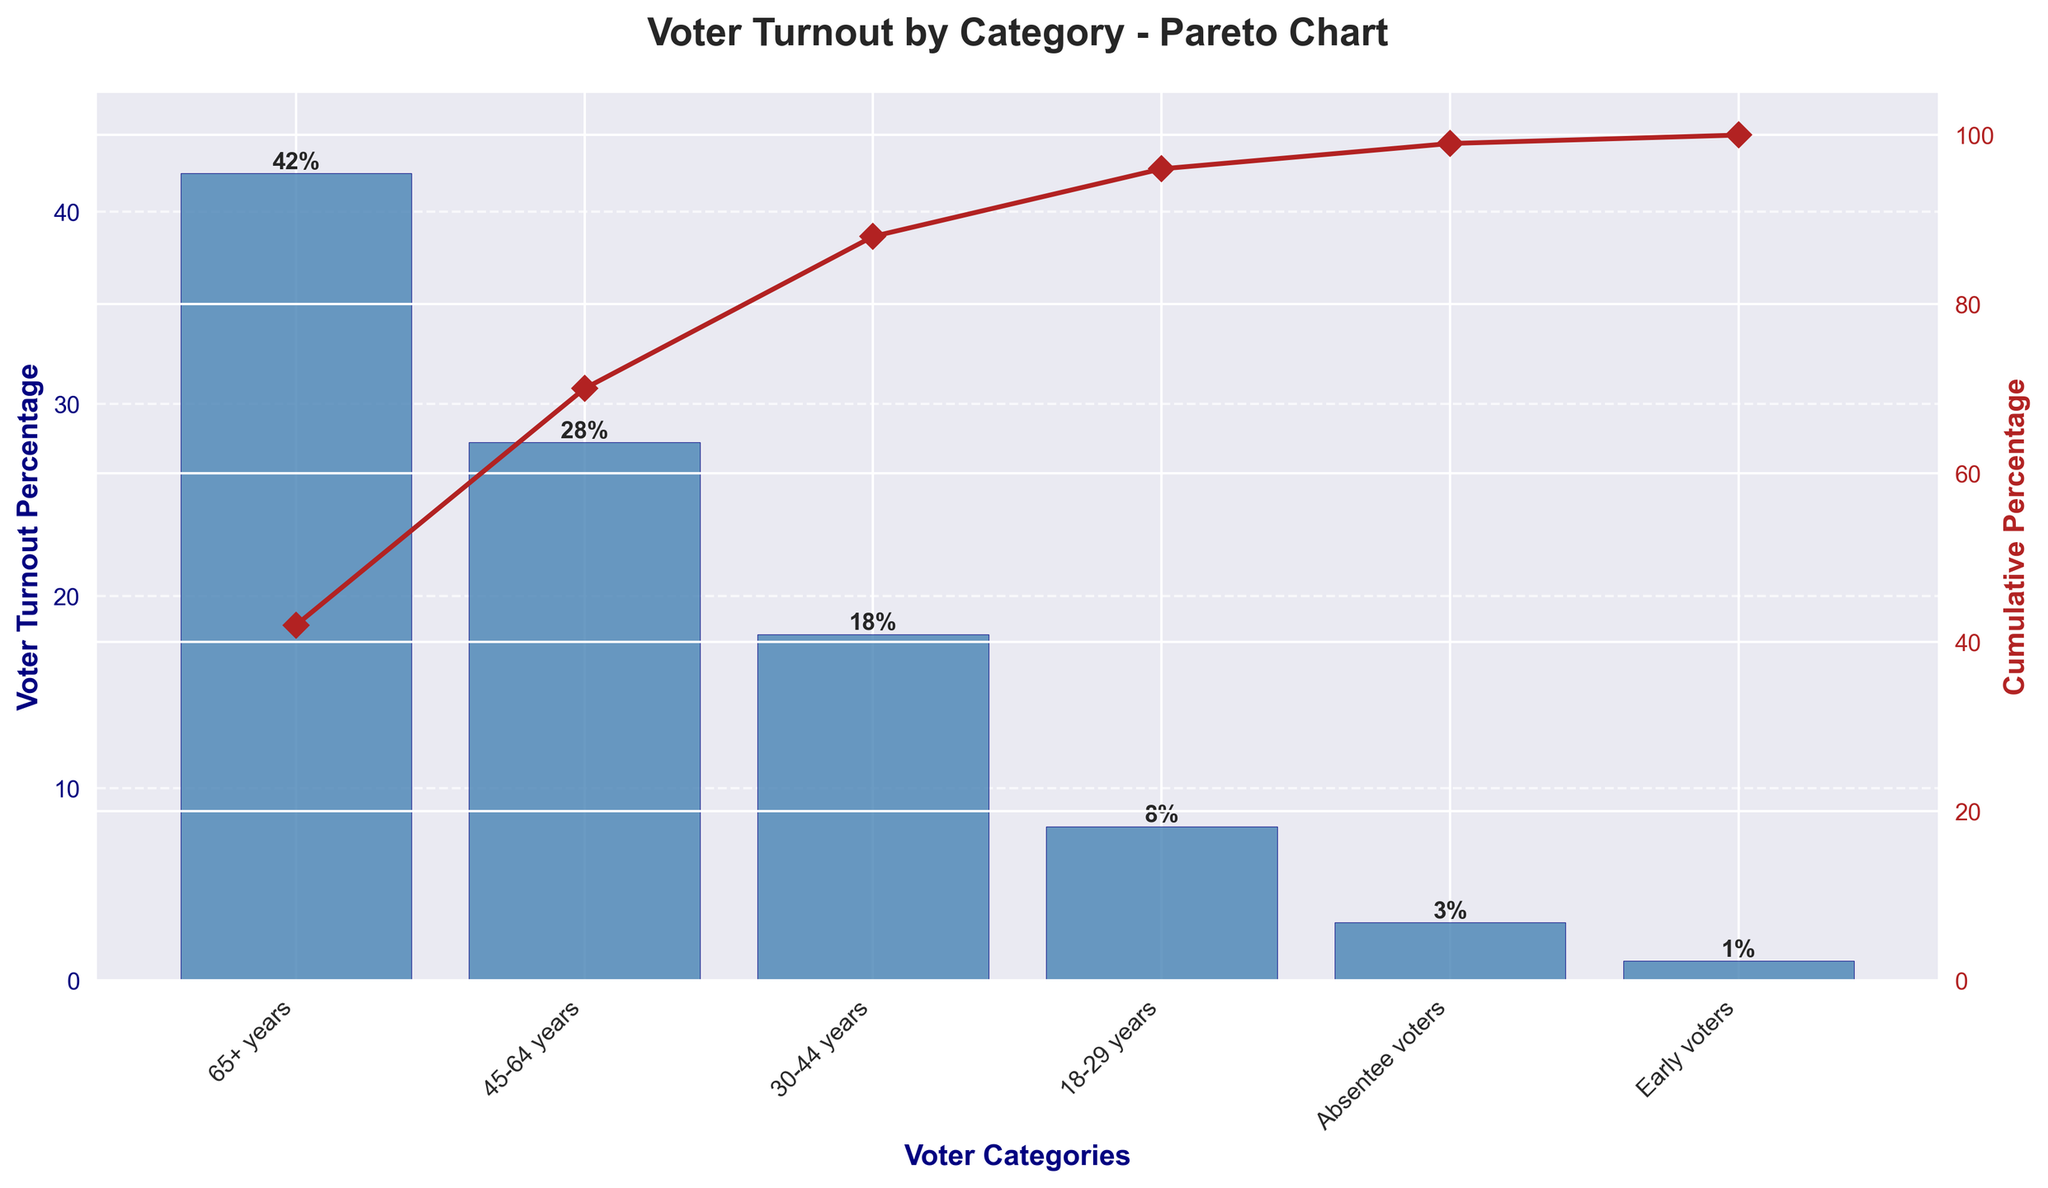What is the title of the figure? The title of the figure is written at the top and is stating the main subject of the chart.
Answer: Voter Turnout by Category - Pareto Chart Which voter category has the highest turnout percentage? The tallest bar in the chart represents the category with the highest voter turnout percentage.
Answer: 65+ years How many categories are shown in the figure? Count the number of different bars shown in the chart.
Answer: 6 What percentage of voter turnout does the 30-44 years category represent? Look for the bar labeled "30-44 years" and note the percentage associated with it.
Answer: 18% Which two categories combined make up exactly 10% of the voter turnout? Identify two bars whose turnout percentages add up to 10%.
Answer: Absentee voters and Early voters Which voter category is 20 percentage points lower than the 45-64 years category? Compare the voter turnout percentage of the 45-64 years category and find a category that is 20 percentage points lower.
Answer: 18-29 years What is the cumulative percentage after adding the turnout from the 45-64 years category? Look at the cumulative percentage line graph and identify its value at the 45-64 years category.
Answer: 70% How many categories collectively contribute to at least 90% of the voter turnout? Sum the cumulative percentages from the left until they surpass 90%.
Answer: 4 Which category has the second lowest voter turnout and what is its percentage? Identify the second shortest bar and note the percentage shown at the top of this bar.
Answer: Absentee voters, 3% What is the combined voter turnout percentage for the 18-29 years and Early voters categories? Add the turnout percentages of the 18-29 years and Early voters categories.
Answer: 9% 